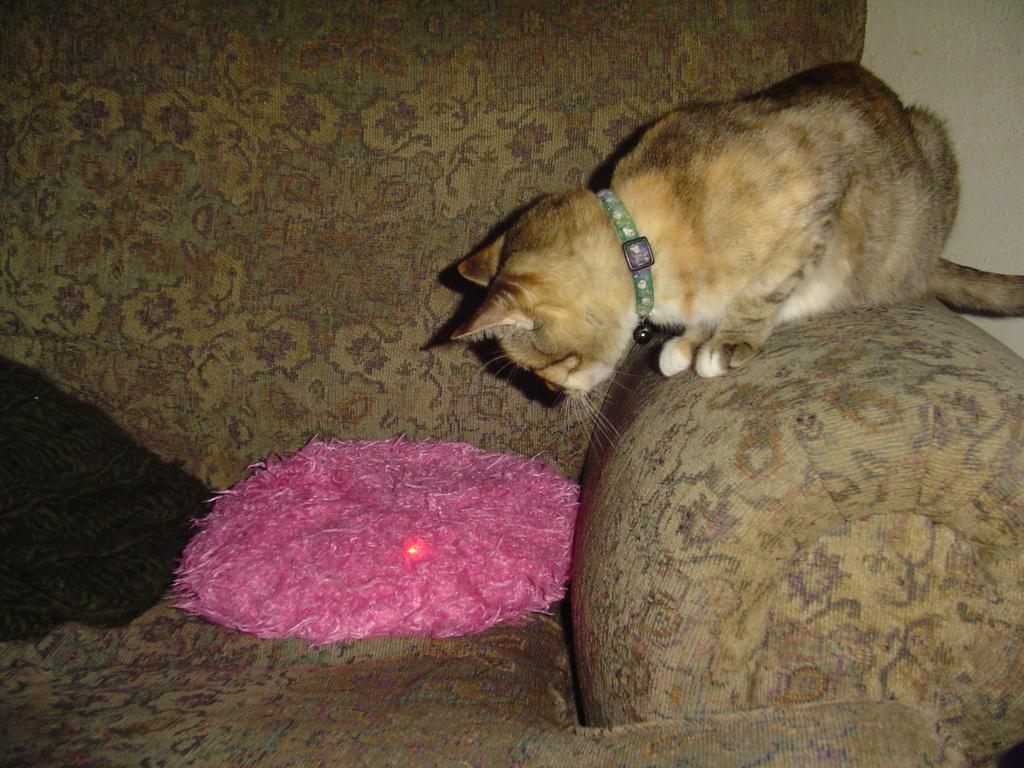What type of animal can be seen in the image? There is an animal in the image, but its specific type cannot be determined from the provided facts. What colors are present on the animal? The animal is brown and white in color. Where is the animal located in the image? The animal is on a couch. What colors can be seen on the objects on the couch? The objects on the couch have pink and black colors. What type of pump is visible in the image? There is no pump present in the image. Is there a church in the background of the image? The provided facts do not mention a church or any background information, so it cannot be determined from the image. 